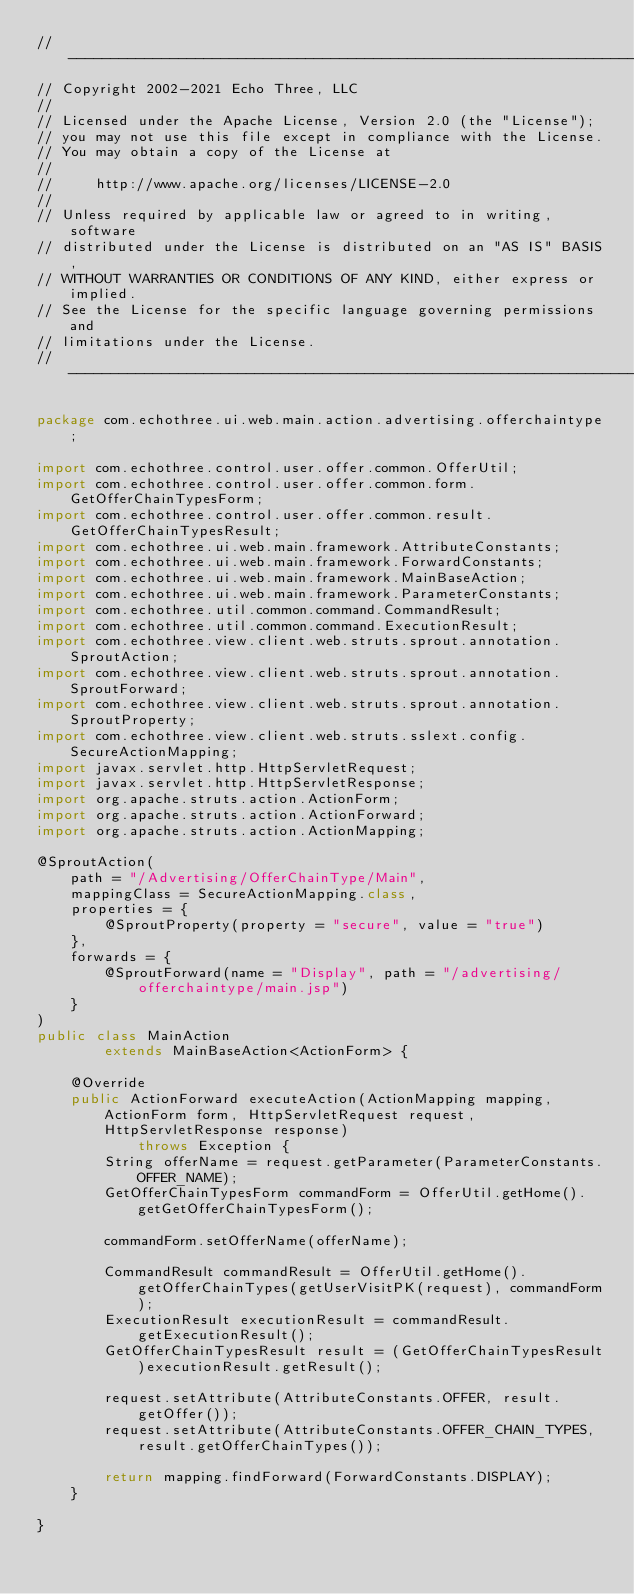<code> <loc_0><loc_0><loc_500><loc_500><_Java_>// --------------------------------------------------------------------------------
// Copyright 2002-2021 Echo Three, LLC
//
// Licensed under the Apache License, Version 2.0 (the "License");
// you may not use this file except in compliance with the License.
// You may obtain a copy of the License at
//
//     http://www.apache.org/licenses/LICENSE-2.0
//
// Unless required by applicable law or agreed to in writing, software
// distributed under the License is distributed on an "AS IS" BASIS,
// WITHOUT WARRANTIES OR CONDITIONS OF ANY KIND, either express or implied.
// See the License for the specific language governing permissions and
// limitations under the License.
// --------------------------------------------------------------------------------

package com.echothree.ui.web.main.action.advertising.offerchaintype;

import com.echothree.control.user.offer.common.OfferUtil;
import com.echothree.control.user.offer.common.form.GetOfferChainTypesForm;
import com.echothree.control.user.offer.common.result.GetOfferChainTypesResult;
import com.echothree.ui.web.main.framework.AttributeConstants;
import com.echothree.ui.web.main.framework.ForwardConstants;
import com.echothree.ui.web.main.framework.MainBaseAction;
import com.echothree.ui.web.main.framework.ParameterConstants;
import com.echothree.util.common.command.CommandResult;
import com.echothree.util.common.command.ExecutionResult;
import com.echothree.view.client.web.struts.sprout.annotation.SproutAction;
import com.echothree.view.client.web.struts.sprout.annotation.SproutForward;
import com.echothree.view.client.web.struts.sprout.annotation.SproutProperty;
import com.echothree.view.client.web.struts.sslext.config.SecureActionMapping;
import javax.servlet.http.HttpServletRequest;
import javax.servlet.http.HttpServletResponse;
import org.apache.struts.action.ActionForm;
import org.apache.struts.action.ActionForward;
import org.apache.struts.action.ActionMapping;

@SproutAction(
    path = "/Advertising/OfferChainType/Main",
    mappingClass = SecureActionMapping.class,
    properties = {
        @SproutProperty(property = "secure", value = "true")
    },
    forwards = {
        @SproutForward(name = "Display", path = "/advertising/offerchaintype/main.jsp")
    }
)
public class MainAction
        extends MainBaseAction<ActionForm> {
    
    @Override
    public ActionForward executeAction(ActionMapping mapping, ActionForm form, HttpServletRequest request, HttpServletResponse response)
            throws Exception {
        String offerName = request.getParameter(ParameterConstants.OFFER_NAME);
        GetOfferChainTypesForm commandForm = OfferUtil.getHome().getGetOfferChainTypesForm();
        
        commandForm.setOfferName(offerName);
        
        CommandResult commandResult = OfferUtil.getHome().getOfferChainTypes(getUserVisitPK(request), commandForm);
        ExecutionResult executionResult = commandResult.getExecutionResult();
        GetOfferChainTypesResult result = (GetOfferChainTypesResult)executionResult.getResult();
        
        request.setAttribute(AttributeConstants.OFFER, result.getOffer());
        request.setAttribute(AttributeConstants.OFFER_CHAIN_TYPES, result.getOfferChainTypes());
        
        return mapping.findForward(ForwardConstants.DISPLAY);
    }
    
}</code> 